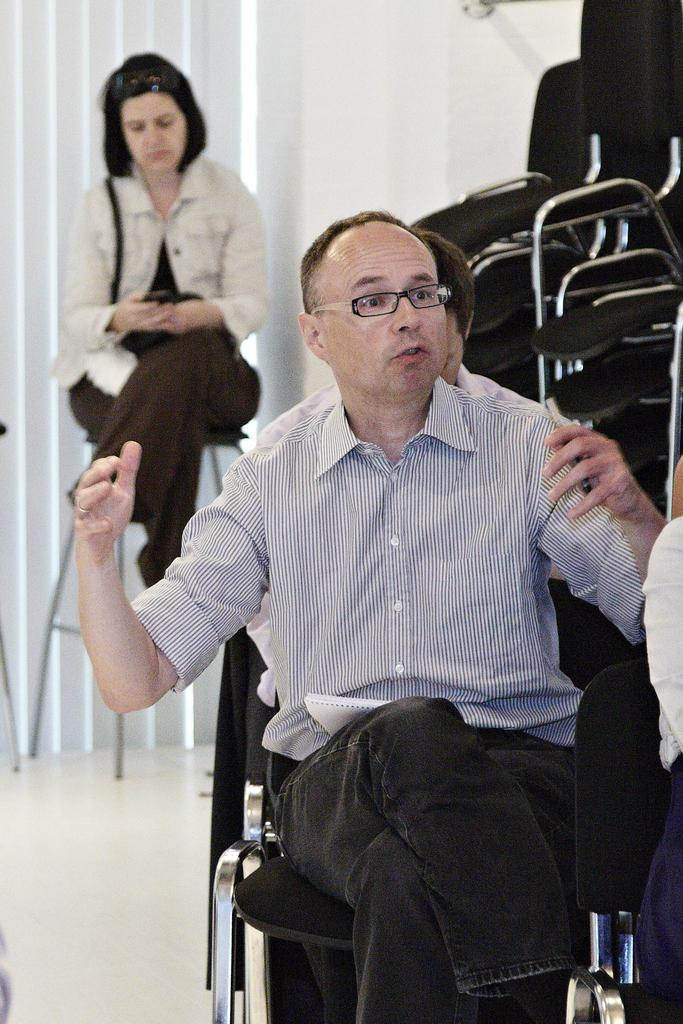How many people are sitting on the chair in the image? There are three people sitting on the chair in the image. Can you describe the gender of the people sitting on the chair? There are two men and one woman sitting on the chair. What is one of the people doing while sitting on the chair? One person is talking while sitting on the chair. What type of powder can be seen falling from the hose in the image? There is no hose or powder present in the image; it features people sitting on a chair. 